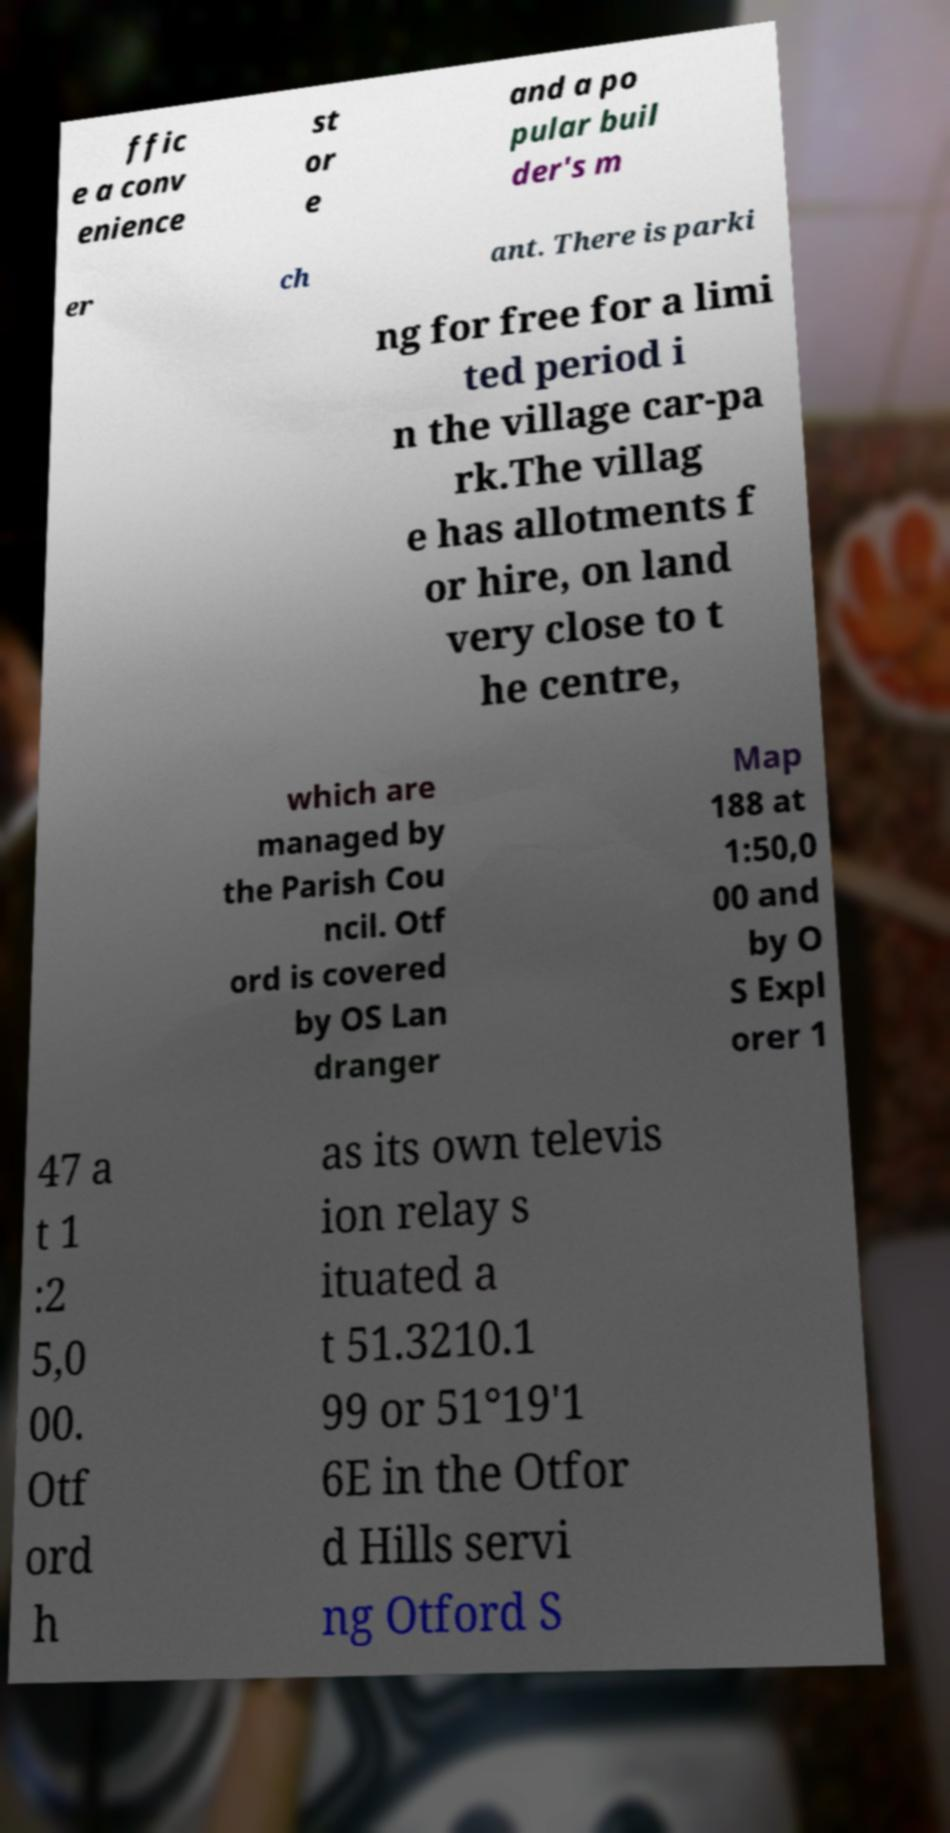There's text embedded in this image that I need extracted. Can you transcribe it verbatim? ffic e a conv enience st or e and a po pular buil der's m er ch ant. There is parki ng for free for a limi ted period i n the village car-pa rk.The villag e has allotments f or hire, on land very close to t he centre, which are managed by the Parish Cou ncil. Otf ord is covered by OS Lan dranger Map 188 at 1:50,0 00 and by O S Expl orer 1 47 a t 1 :2 5,0 00. Otf ord h as its own televis ion relay s ituated a t 51.3210.1 99 or 51°19'1 6E in the Otfor d Hills servi ng Otford S 